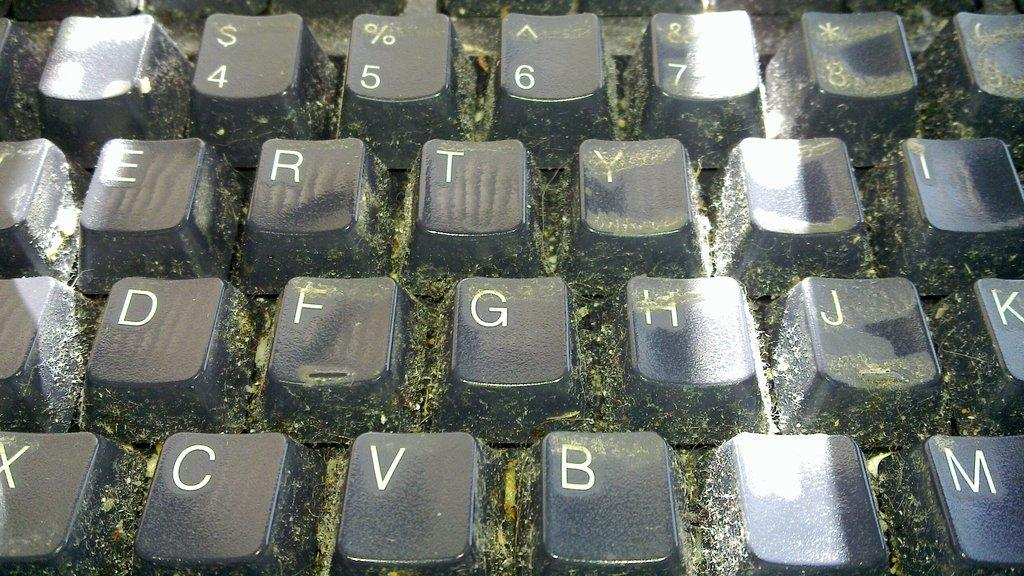<image>
Describe the image concisely. A computer keyboard with keys containing letters such as e, r and t. 